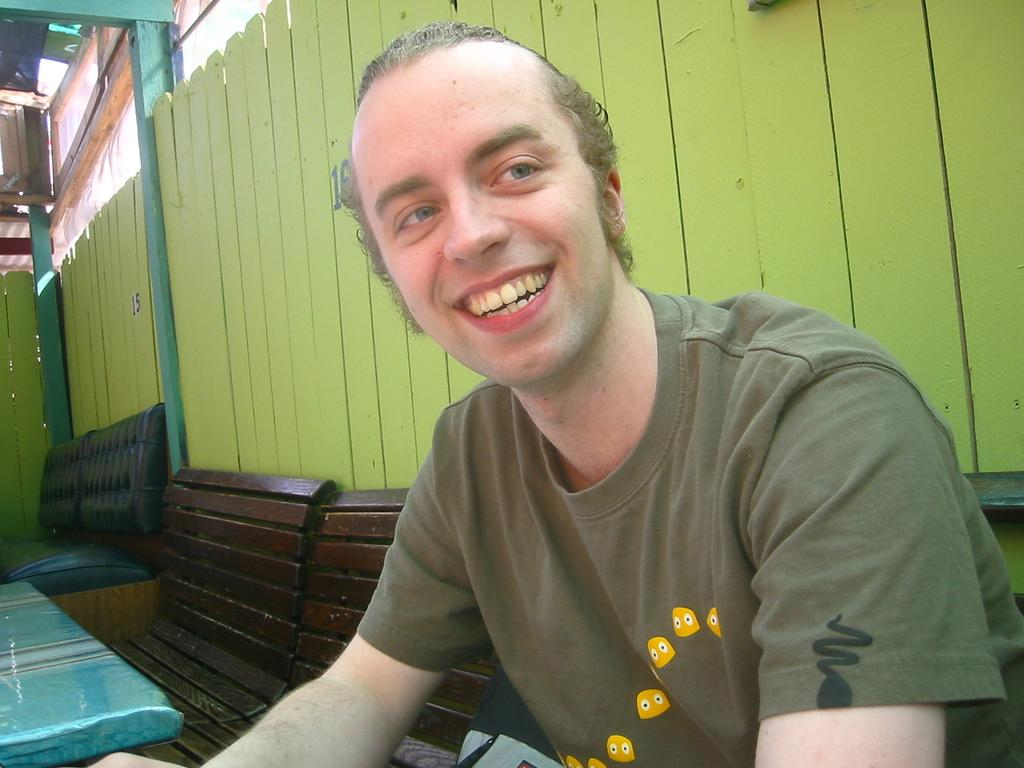What is the man in the image doing? The man is sitting on a bench in the image. What is the man wearing? The man is wearing a cream t-shirt. What type of seating can be seen towards the left side of the image? There are benches and a sofa towards the left side of the image. What is behind the man in the image? There is a wooden wall behind the man. What type of grain is the man eating in the image? There is no grain present in the image, and the man is not eating anything. 